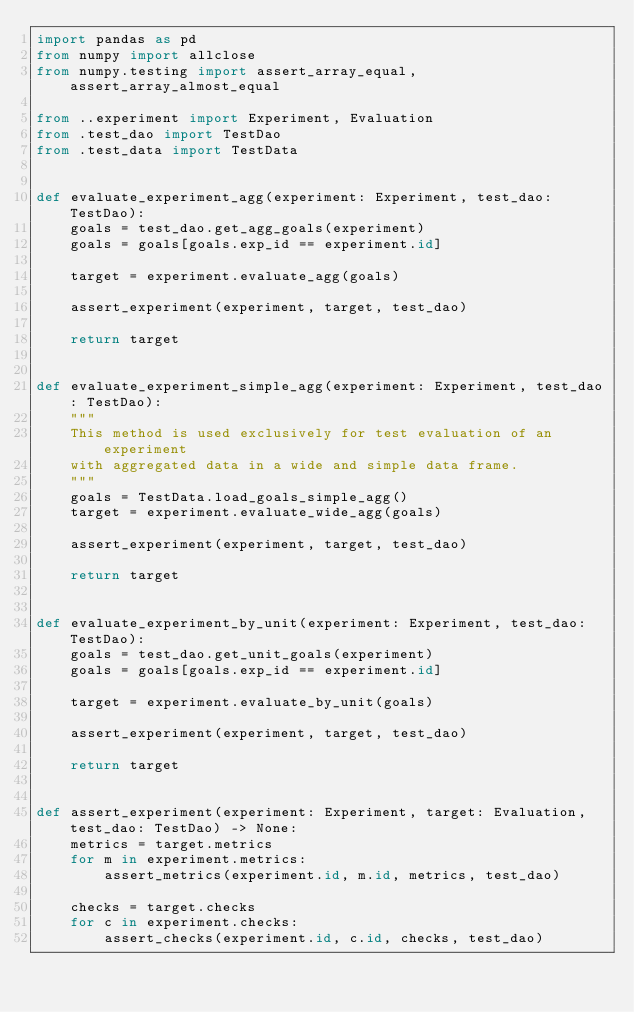Convert code to text. <code><loc_0><loc_0><loc_500><loc_500><_Python_>import pandas as pd
from numpy import allclose
from numpy.testing import assert_array_equal, assert_array_almost_equal

from ..experiment import Experiment, Evaluation
from .test_dao import TestDao
from .test_data import TestData


def evaluate_experiment_agg(experiment: Experiment, test_dao: TestDao):
    goals = test_dao.get_agg_goals(experiment)
    goals = goals[goals.exp_id == experiment.id]

    target = experiment.evaluate_agg(goals)

    assert_experiment(experiment, target, test_dao)

    return target


def evaluate_experiment_simple_agg(experiment: Experiment, test_dao: TestDao):
    """
    This method is used exclusively for test evaluation of an experiment
    with aggregated data in a wide and simple data frame.
    """
    goals = TestData.load_goals_simple_agg()
    target = experiment.evaluate_wide_agg(goals)

    assert_experiment(experiment, target, test_dao)

    return target


def evaluate_experiment_by_unit(experiment: Experiment, test_dao: TestDao):
    goals = test_dao.get_unit_goals(experiment)
    goals = goals[goals.exp_id == experiment.id]

    target = experiment.evaluate_by_unit(goals)

    assert_experiment(experiment, target, test_dao)

    return target


def assert_experiment(experiment: Experiment, target: Evaluation, test_dao: TestDao) -> None:
    metrics = target.metrics
    for m in experiment.metrics:
        assert_metrics(experiment.id, m.id, metrics, test_dao)

    checks = target.checks
    for c in experiment.checks:
        assert_checks(experiment.id, c.id, checks, test_dao)
</code> 